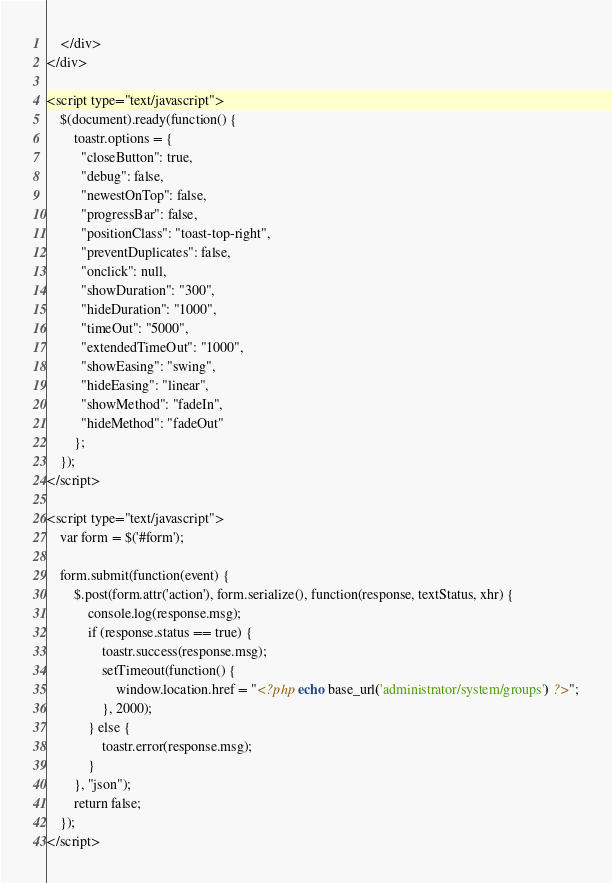<code> <loc_0><loc_0><loc_500><loc_500><_PHP_>	</div>
</div>

<script type="text/javascript">
	$(document).ready(function() {
		toastr.options = {
		  "closeButton": true,
		  "debug": false,
		  "newestOnTop": false,
		  "progressBar": false,
		  "positionClass": "toast-top-right",
		  "preventDuplicates": false,
		  "onclick": null,
		  "showDuration": "300",
		  "hideDuration": "1000",
		  "timeOut": "5000",
		  "extendedTimeOut": "1000",
		  "showEasing": "swing",
		  "hideEasing": "linear",
		  "showMethod": "fadeIn",
		  "hideMethod": "fadeOut"
		};
	});
</script>

<script type="text/javascript">
	var form = $('#form');

	form.submit(function(event) {
		$.post(form.attr('action'), form.serialize(), function(response, textStatus, xhr) {
			console.log(response.msg);
			if (response.status == true) {
				toastr.success(response.msg);
				setTimeout(function() {
					window.location.href = "<?php echo base_url('administrator/system/groups') ?>";
				}, 2000);
			} else {
				toastr.error(response.msg);
			}
		}, "json");
		return false;
	});
</script></code> 